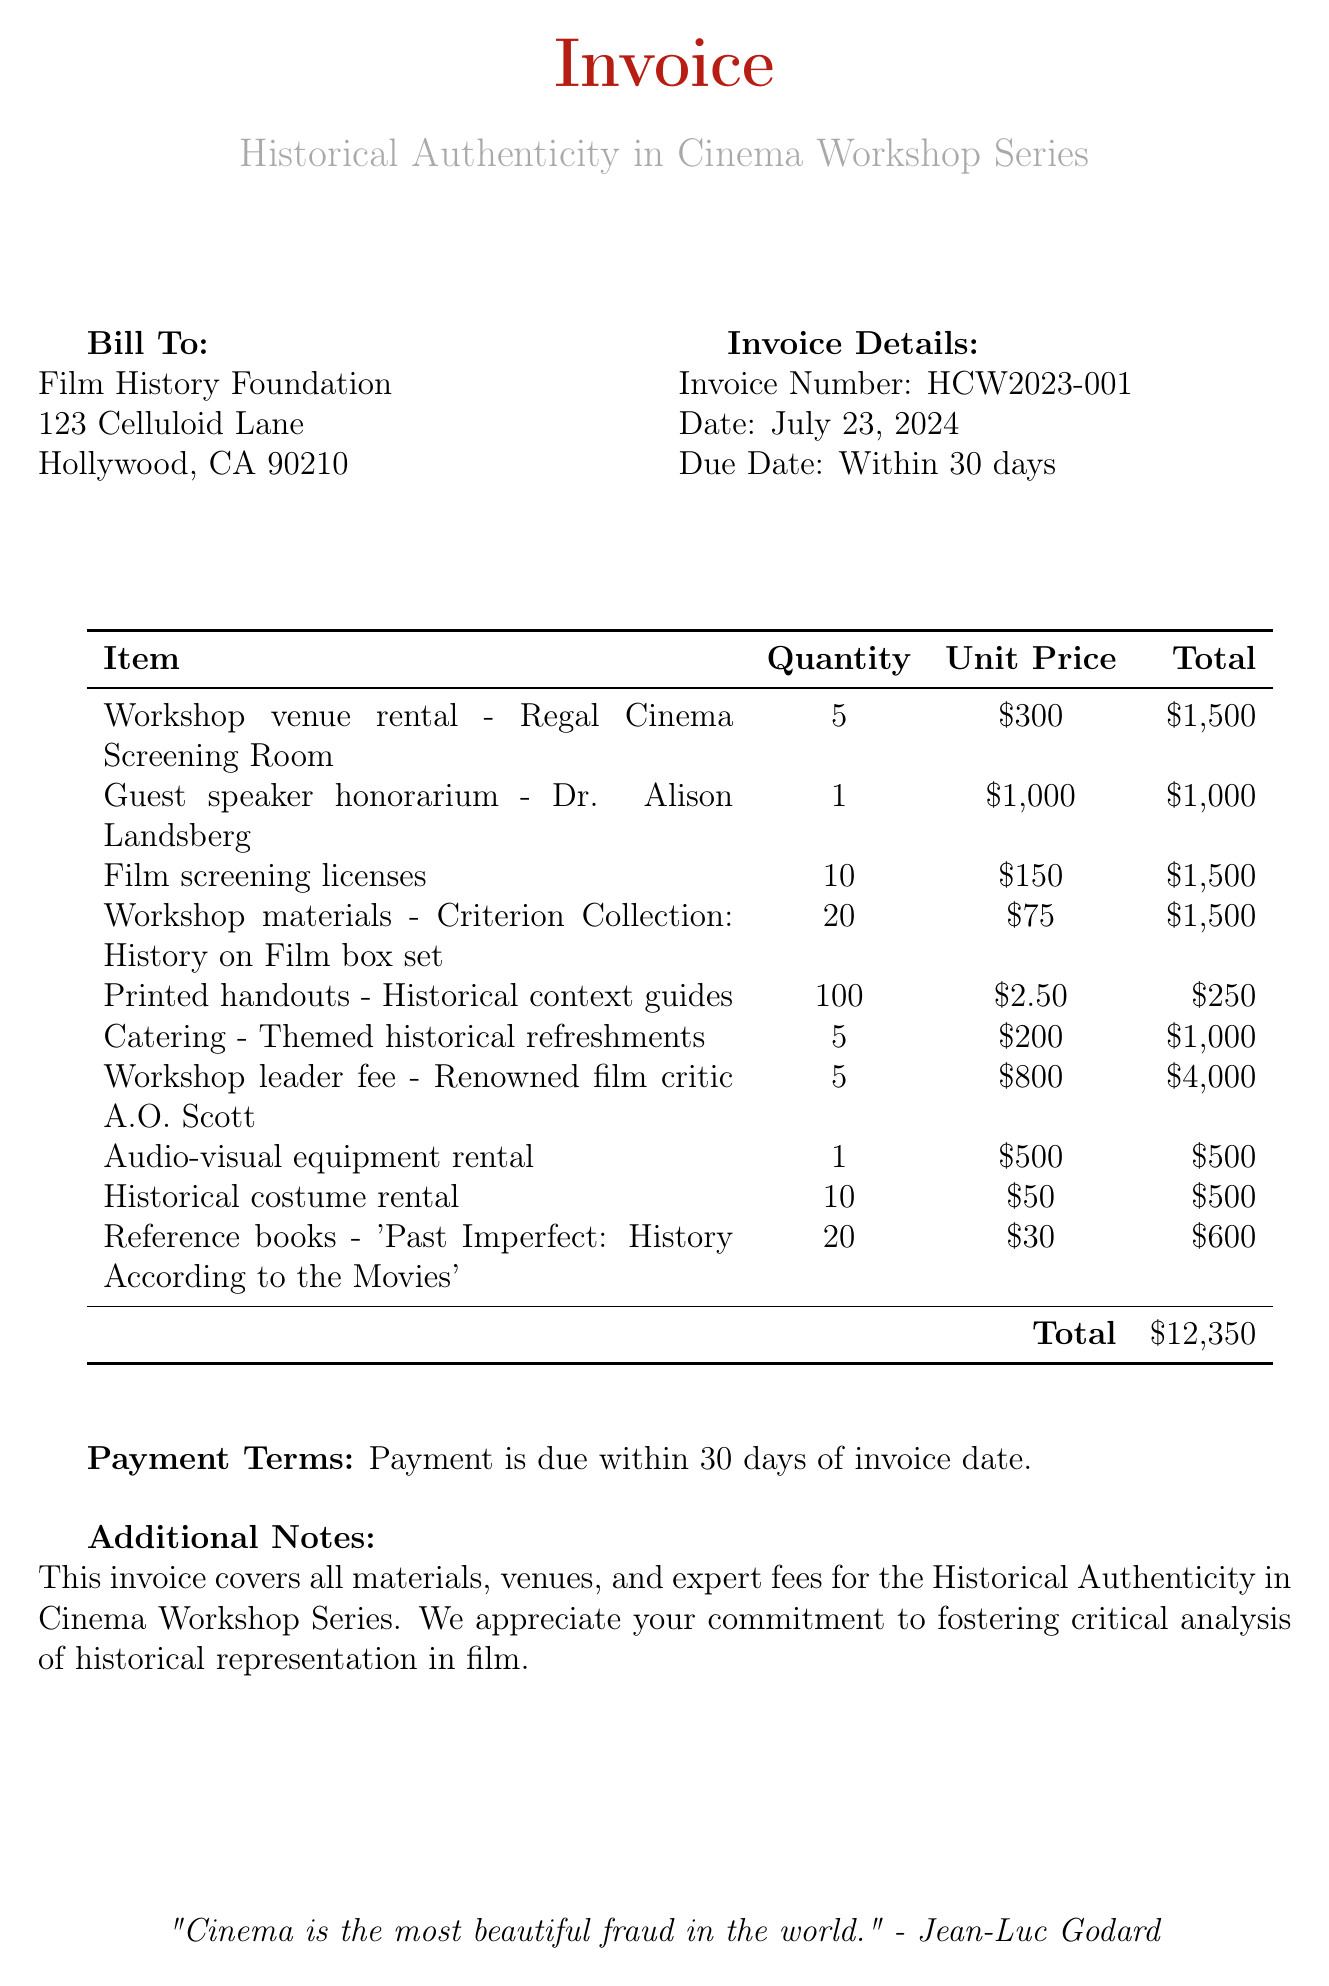What is the invoice number? The invoice number is mentioned in the invoice details section.
Answer: HCW2023-001 How many workshops does the venue rental cover? The quantity for the venue rental is specified in the document.
Answer: 5 Who is the guest speaker? The guest speaker is listed with an honorarium in the document.
Answer: Dr. Alison Landsberg What is the total cost for the workshop materials? The total cost for the workshop materials is calculated from the quantity and unit price in the invoice.
Answer: $1,500 What is the unit price for the film screening licenses? The unit price is specified in the table of items in the document.
Answer: $150 How much is charged for catering? The total for catering is noted in the invoice table.
Answer: $1,000 What is the total amount due for the invoice? The total amount due is summarized at the bottom of the invoice.
Answer: $12,350 What type of refreshments are provided? The description under the catering item specifies the nature of the refreshments.
Answer: Themed historical refreshments How many reference books are being rented? The quantity of reference books is provided in the invoice table.
Answer: 20 